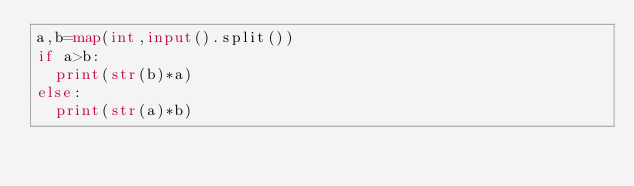<code> <loc_0><loc_0><loc_500><loc_500><_Python_>a,b=map(int,input().split())
if a>b:
	print(str(b)*a)
else:
	print(str(a)*b)</code> 